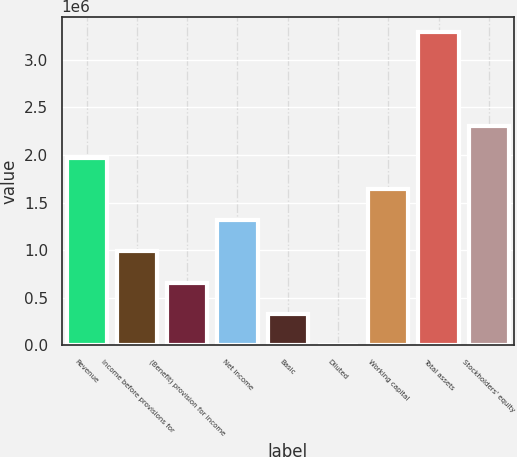<chart> <loc_0><loc_0><loc_500><loc_500><bar_chart><fcel>Revenue<fcel>Income before provisions for<fcel>(Benefit) provision for income<fcel>Net income<fcel>Basic<fcel>Diluted<fcel>Working capital<fcel>Total assets<fcel>Stockholders' equity<nl><fcel>1.97193e+06<fcel>985963<fcel>657309<fcel>1.31462e+06<fcel>328656<fcel>1.56<fcel>1.64327e+06<fcel>3.28654e+06<fcel>2.30058e+06<nl></chart> 